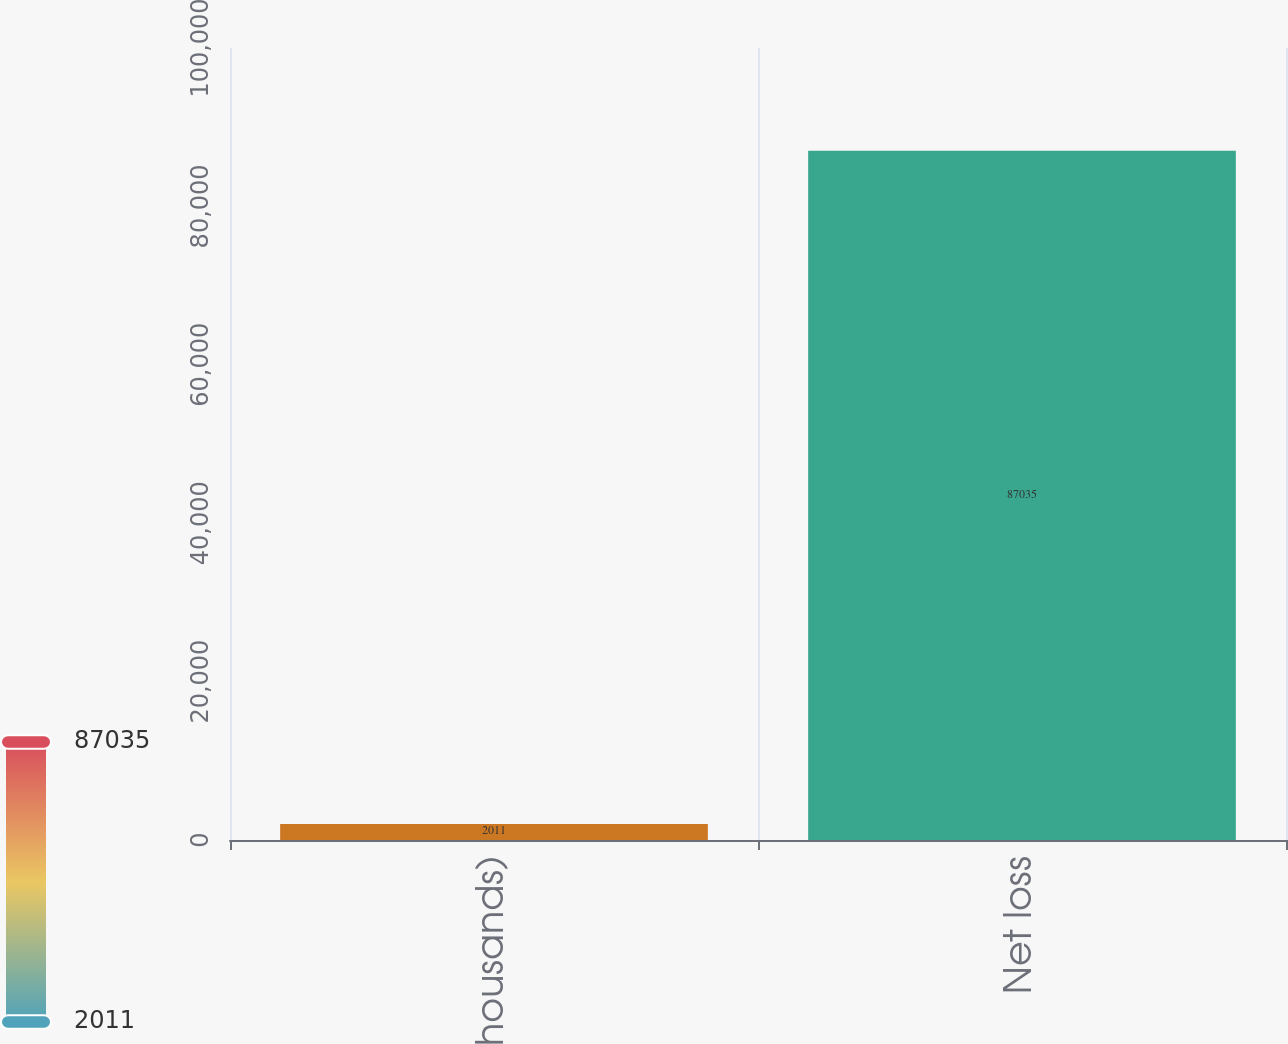<chart> <loc_0><loc_0><loc_500><loc_500><bar_chart><fcel>(in thousands)<fcel>Net loss<nl><fcel>2011<fcel>87035<nl></chart> 